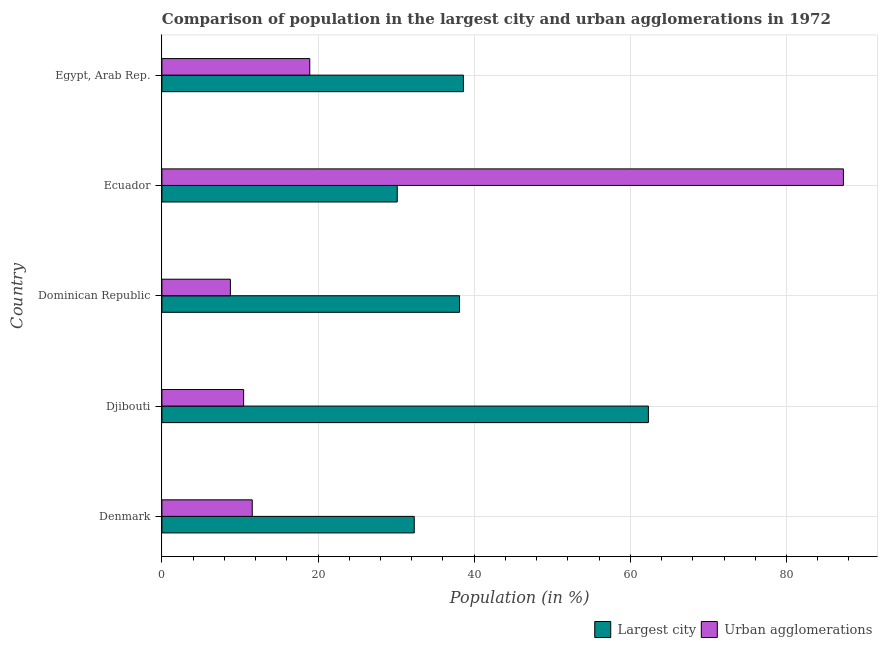How many different coloured bars are there?
Keep it short and to the point. 2. Are the number of bars on each tick of the Y-axis equal?
Make the answer very short. Yes. How many bars are there on the 3rd tick from the bottom?
Provide a succinct answer. 2. What is the label of the 1st group of bars from the top?
Your answer should be very brief. Egypt, Arab Rep. What is the population in the largest city in Djibouti?
Give a very brief answer. 62.31. Across all countries, what is the maximum population in the largest city?
Provide a short and direct response. 62.31. Across all countries, what is the minimum population in the largest city?
Ensure brevity in your answer.  30.14. In which country was the population in urban agglomerations maximum?
Offer a very short reply. Ecuador. In which country was the population in urban agglomerations minimum?
Your answer should be compact. Dominican Republic. What is the total population in the largest city in the graph?
Offer a terse response. 201.52. What is the difference between the population in urban agglomerations in Denmark and that in Egypt, Arab Rep.?
Your response must be concise. -7.37. What is the difference between the population in urban agglomerations in Ecuador and the population in the largest city in Dominican Republic?
Make the answer very short. 49.17. What is the average population in the largest city per country?
Provide a short and direct response. 40.3. What is the difference between the population in urban agglomerations and population in the largest city in Egypt, Arab Rep.?
Provide a short and direct response. -19.68. In how many countries, is the population in urban agglomerations greater than 4 %?
Your response must be concise. 5. What is the ratio of the population in the largest city in Dominican Republic to that in Egypt, Arab Rep.?
Make the answer very short. 0.99. What is the difference between the highest and the second highest population in urban agglomerations?
Offer a very short reply. 68.35. What is the difference between the highest and the lowest population in the largest city?
Offer a terse response. 32.17. In how many countries, is the population in the largest city greater than the average population in the largest city taken over all countries?
Offer a terse response. 1. Is the sum of the population in urban agglomerations in Dominican Republic and Egypt, Arab Rep. greater than the maximum population in the largest city across all countries?
Provide a succinct answer. No. What does the 1st bar from the top in Denmark represents?
Your answer should be very brief. Urban agglomerations. What does the 2nd bar from the bottom in Dominican Republic represents?
Your answer should be very brief. Urban agglomerations. How many countries are there in the graph?
Your response must be concise. 5. Where does the legend appear in the graph?
Your response must be concise. Bottom right. What is the title of the graph?
Ensure brevity in your answer.  Comparison of population in the largest city and urban agglomerations in 1972. Does "Female entrants" appear as one of the legend labels in the graph?
Keep it short and to the point. No. What is the label or title of the Y-axis?
Offer a very short reply. Country. What is the Population (in %) in Largest city in Denmark?
Offer a terse response. 32.32. What is the Population (in %) of Urban agglomerations in Denmark?
Make the answer very short. 11.57. What is the Population (in %) of Largest city in Djibouti?
Provide a short and direct response. 62.31. What is the Population (in %) in Urban agglomerations in Djibouti?
Ensure brevity in your answer.  10.47. What is the Population (in %) of Largest city in Dominican Republic?
Keep it short and to the point. 38.12. What is the Population (in %) of Urban agglomerations in Dominican Republic?
Ensure brevity in your answer.  8.77. What is the Population (in %) of Largest city in Ecuador?
Offer a very short reply. 30.14. What is the Population (in %) of Urban agglomerations in Ecuador?
Provide a short and direct response. 87.29. What is the Population (in %) in Largest city in Egypt, Arab Rep.?
Offer a very short reply. 38.62. What is the Population (in %) of Urban agglomerations in Egypt, Arab Rep.?
Give a very brief answer. 18.94. Across all countries, what is the maximum Population (in %) of Largest city?
Provide a short and direct response. 62.31. Across all countries, what is the maximum Population (in %) of Urban agglomerations?
Your answer should be compact. 87.29. Across all countries, what is the minimum Population (in %) of Largest city?
Your response must be concise. 30.14. Across all countries, what is the minimum Population (in %) in Urban agglomerations?
Offer a terse response. 8.77. What is the total Population (in %) in Largest city in the graph?
Offer a very short reply. 201.52. What is the total Population (in %) in Urban agglomerations in the graph?
Your response must be concise. 137.04. What is the difference between the Population (in %) in Largest city in Denmark and that in Djibouti?
Your answer should be very brief. -29.99. What is the difference between the Population (in %) of Urban agglomerations in Denmark and that in Djibouti?
Offer a very short reply. 1.1. What is the difference between the Population (in %) of Largest city in Denmark and that in Dominican Republic?
Provide a succinct answer. -5.8. What is the difference between the Population (in %) of Urban agglomerations in Denmark and that in Dominican Republic?
Provide a short and direct response. 2.8. What is the difference between the Population (in %) of Largest city in Denmark and that in Ecuador?
Ensure brevity in your answer.  2.18. What is the difference between the Population (in %) of Urban agglomerations in Denmark and that in Ecuador?
Ensure brevity in your answer.  -75.72. What is the difference between the Population (in %) of Largest city in Denmark and that in Egypt, Arab Rep.?
Keep it short and to the point. -6.3. What is the difference between the Population (in %) of Urban agglomerations in Denmark and that in Egypt, Arab Rep.?
Ensure brevity in your answer.  -7.37. What is the difference between the Population (in %) of Largest city in Djibouti and that in Dominican Republic?
Offer a terse response. 24.19. What is the difference between the Population (in %) in Urban agglomerations in Djibouti and that in Dominican Republic?
Offer a terse response. 1.7. What is the difference between the Population (in %) in Largest city in Djibouti and that in Ecuador?
Make the answer very short. 32.17. What is the difference between the Population (in %) in Urban agglomerations in Djibouti and that in Ecuador?
Make the answer very short. -76.82. What is the difference between the Population (in %) in Largest city in Djibouti and that in Egypt, Arab Rep.?
Offer a very short reply. 23.7. What is the difference between the Population (in %) of Urban agglomerations in Djibouti and that in Egypt, Arab Rep.?
Provide a succinct answer. -8.47. What is the difference between the Population (in %) of Largest city in Dominican Republic and that in Ecuador?
Offer a very short reply. 7.98. What is the difference between the Population (in %) of Urban agglomerations in Dominican Republic and that in Ecuador?
Provide a succinct answer. -78.52. What is the difference between the Population (in %) in Largest city in Dominican Republic and that in Egypt, Arab Rep.?
Keep it short and to the point. -0.49. What is the difference between the Population (in %) of Urban agglomerations in Dominican Republic and that in Egypt, Arab Rep.?
Keep it short and to the point. -10.17. What is the difference between the Population (in %) in Largest city in Ecuador and that in Egypt, Arab Rep.?
Make the answer very short. -8.47. What is the difference between the Population (in %) of Urban agglomerations in Ecuador and that in Egypt, Arab Rep.?
Give a very brief answer. 68.35. What is the difference between the Population (in %) in Largest city in Denmark and the Population (in %) in Urban agglomerations in Djibouti?
Provide a short and direct response. 21.85. What is the difference between the Population (in %) in Largest city in Denmark and the Population (in %) in Urban agglomerations in Dominican Republic?
Your answer should be compact. 23.55. What is the difference between the Population (in %) of Largest city in Denmark and the Population (in %) of Urban agglomerations in Ecuador?
Provide a short and direct response. -54.97. What is the difference between the Population (in %) in Largest city in Denmark and the Population (in %) in Urban agglomerations in Egypt, Arab Rep.?
Ensure brevity in your answer.  13.38. What is the difference between the Population (in %) in Largest city in Djibouti and the Population (in %) in Urban agglomerations in Dominican Republic?
Your response must be concise. 53.54. What is the difference between the Population (in %) of Largest city in Djibouti and the Population (in %) of Urban agglomerations in Ecuador?
Provide a succinct answer. -24.98. What is the difference between the Population (in %) in Largest city in Djibouti and the Population (in %) in Urban agglomerations in Egypt, Arab Rep.?
Offer a terse response. 43.37. What is the difference between the Population (in %) of Largest city in Dominican Republic and the Population (in %) of Urban agglomerations in Ecuador?
Make the answer very short. -49.17. What is the difference between the Population (in %) of Largest city in Dominican Republic and the Population (in %) of Urban agglomerations in Egypt, Arab Rep.?
Your answer should be very brief. 19.19. What is the difference between the Population (in %) of Largest city in Ecuador and the Population (in %) of Urban agglomerations in Egypt, Arab Rep.?
Offer a very short reply. 11.2. What is the average Population (in %) in Largest city per country?
Your response must be concise. 40.3. What is the average Population (in %) of Urban agglomerations per country?
Your answer should be very brief. 27.41. What is the difference between the Population (in %) of Largest city and Population (in %) of Urban agglomerations in Denmark?
Keep it short and to the point. 20.75. What is the difference between the Population (in %) of Largest city and Population (in %) of Urban agglomerations in Djibouti?
Give a very brief answer. 51.84. What is the difference between the Population (in %) in Largest city and Population (in %) in Urban agglomerations in Dominican Republic?
Your answer should be compact. 29.35. What is the difference between the Population (in %) in Largest city and Population (in %) in Urban agglomerations in Ecuador?
Keep it short and to the point. -57.15. What is the difference between the Population (in %) in Largest city and Population (in %) in Urban agglomerations in Egypt, Arab Rep.?
Keep it short and to the point. 19.68. What is the ratio of the Population (in %) of Largest city in Denmark to that in Djibouti?
Give a very brief answer. 0.52. What is the ratio of the Population (in %) of Urban agglomerations in Denmark to that in Djibouti?
Make the answer very short. 1.11. What is the ratio of the Population (in %) in Largest city in Denmark to that in Dominican Republic?
Your answer should be very brief. 0.85. What is the ratio of the Population (in %) in Urban agglomerations in Denmark to that in Dominican Republic?
Offer a terse response. 1.32. What is the ratio of the Population (in %) of Largest city in Denmark to that in Ecuador?
Provide a short and direct response. 1.07. What is the ratio of the Population (in %) in Urban agglomerations in Denmark to that in Ecuador?
Make the answer very short. 0.13. What is the ratio of the Population (in %) of Largest city in Denmark to that in Egypt, Arab Rep.?
Keep it short and to the point. 0.84. What is the ratio of the Population (in %) of Urban agglomerations in Denmark to that in Egypt, Arab Rep.?
Provide a short and direct response. 0.61. What is the ratio of the Population (in %) in Largest city in Djibouti to that in Dominican Republic?
Make the answer very short. 1.63. What is the ratio of the Population (in %) in Urban agglomerations in Djibouti to that in Dominican Republic?
Keep it short and to the point. 1.19. What is the ratio of the Population (in %) in Largest city in Djibouti to that in Ecuador?
Offer a terse response. 2.07. What is the ratio of the Population (in %) in Urban agglomerations in Djibouti to that in Ecuador?
Provide a succinct answer. 0.12. What is the ratio of the Population (in %) of Largest city in Djibouti to that in Egypt, Arab Rep.?
Provide a succinct answer. 1.61. What is the ratio of the Population (in %) in Urban agglomerations in Djibouti to that in Egypt, Arab Rep.?
Provide a short and direct response. 0.55. What is the ratio of the Population (in %) of Largest city in Dominican Republic to that in Ecuador?
Your answer should be compact. 1.26. What is the ratio of the Population (in %) of Urban agglomerations in Dominican Republic to that in Ecuador?
Make the answer very short. 0.1. What is the ratio of the Population (in %) in Largest city in Dominican Republic to that in Egypt, Arab Rep.?
Ensure brevity in your answer.  0.99. What is the ratio of the Population (in %) in Urban agglomerations in Dominican Republic to that in Egypt, Arab Rep.?
Provide a succinct answer. 0.46. What is the ratio of the Population (in %) of Largest city in Ecuador to that in Egypt, Arab Rep.?
Provide a short and direct response. 0.78. What is the ratio of the Population (in %) in Urban agglomerations in Ecuador to that in Egypt, Arab Rep.?
Provide a succinct answer. 4.61. What is the difference between the highest and the second highest Population (in %) of Largest city?
Your answer should be compact. 23.7. What is the difference between the highest and the second highest Population (in %) in Urban agglomerations?
Provide a short and direct response. 68.35. What is the difference between the highest and the lowest Population (in %) of Largest city?
Offer a very short reply. 32.17. What is the difference between the highest and the lowest Population (in %) in Urban agglomerations?
Your answer should be very brief. 78.52. 